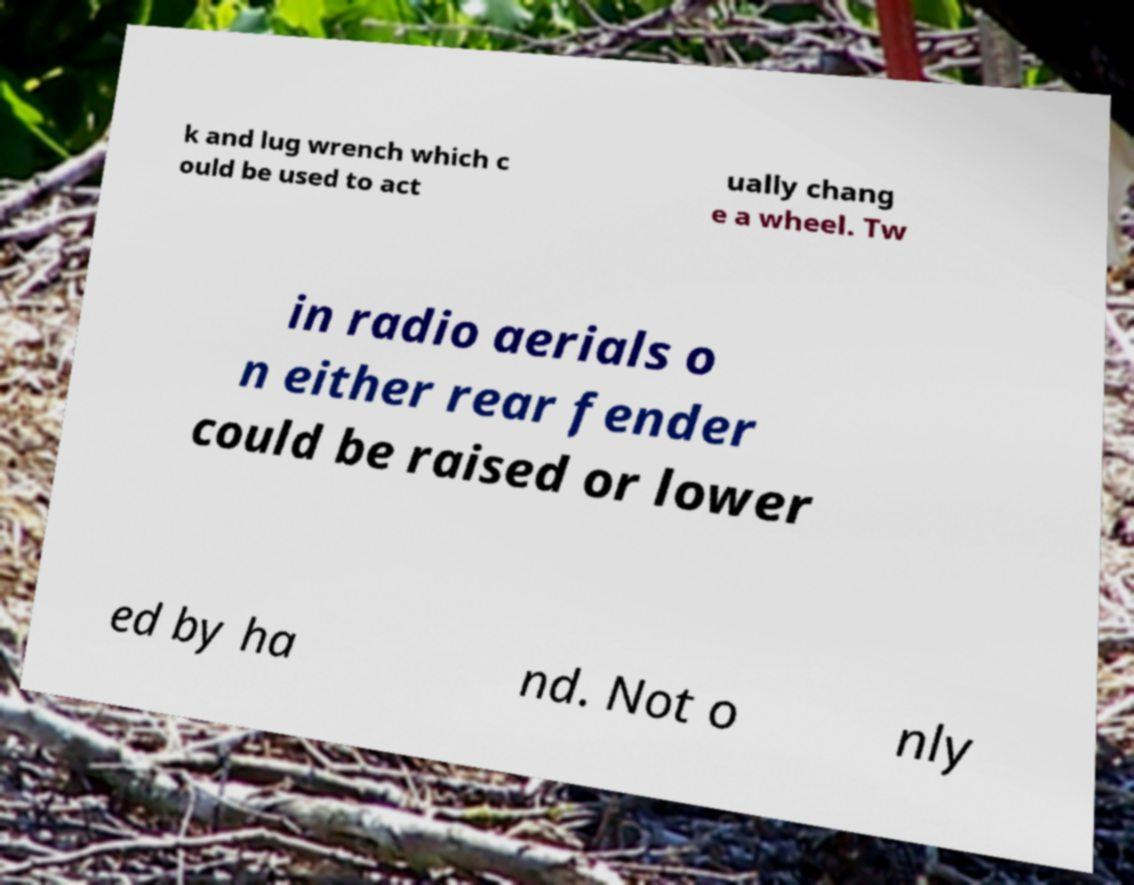There's text embedded in this image that I need extracted. Can you transcribe it verbatim? k and lug wrench which c ould be used to act ually chang e a wheel. Tw in radio aerials o n either rear fender could be raised or lower ed by ha nd. Not o nly 